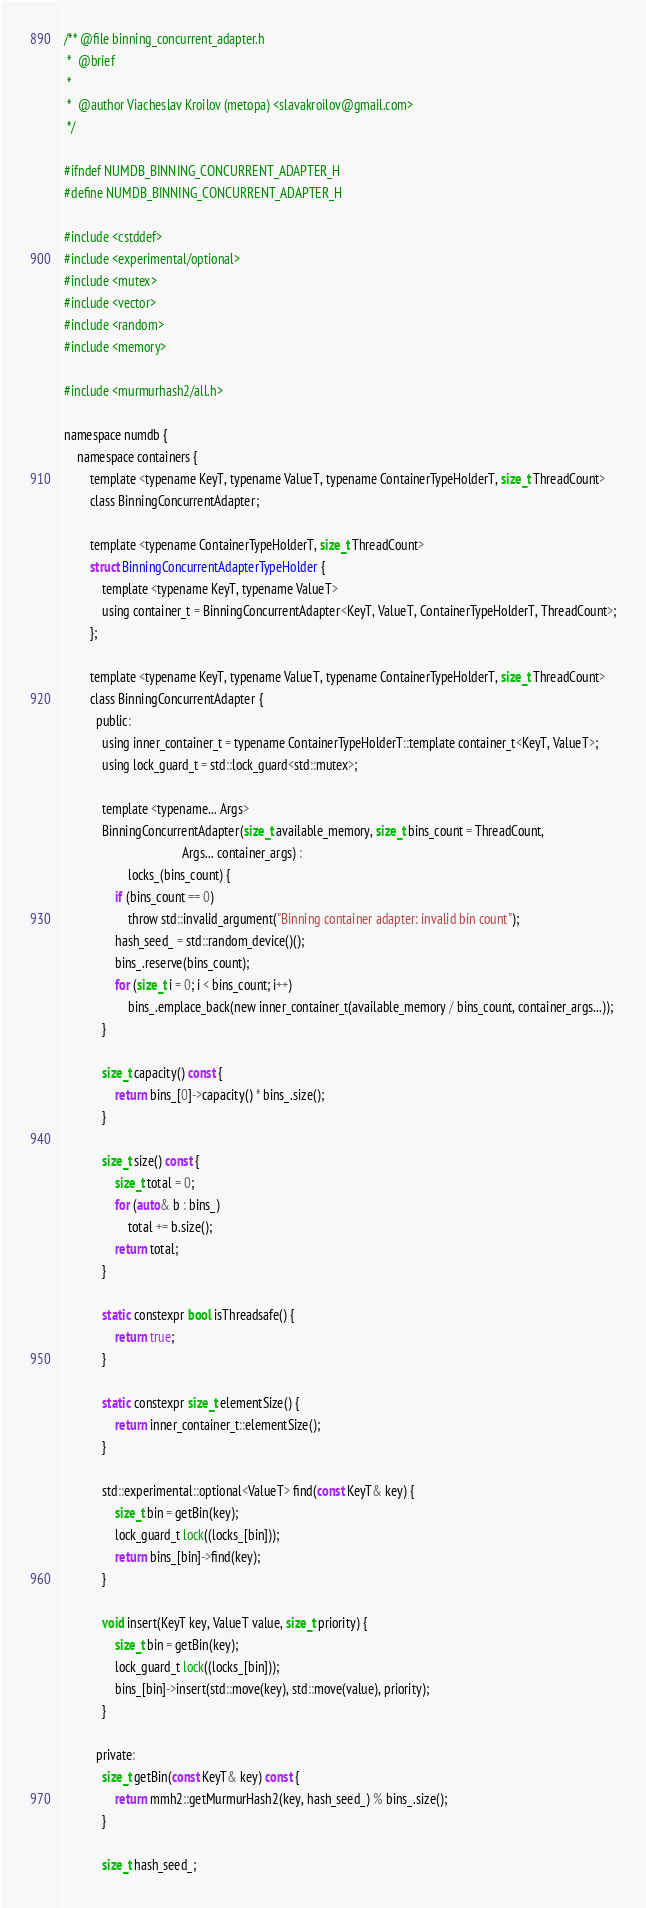Convert code to text. <code><loc_0><loc_0><loc_500><loc_500><_C_>/** @file binning_concurrent_adapter.h
 *  @brief
 *
 *  @author Viacheslav Kroilov (metopa) <slavakroilov@gmail.com>
 */

#ifndef NUMDB_BINNING_CONCURRENT_ADAPTER_H
#define NUMDB_BINNING_CONCURRENT_ADAPTER_H

#include <cstddef>
#include <experimental/optional>
#include <mutex>
#include <vector>
#include <random>
#include <memory>

#include <murmurhash2/all.h>

namespace numdb {
	namespace containers {
		template <typename KeyT, typename ValueT, typename ContainerTypeHolderT, size_t ThreadCount>
		class BinningConcurrentAdapter;

		template <typename ContainerTypeHolderT, size_t ThreadCount>
		struct BinningConcurrentAdapterTypeHolder {
			template <typename KeyT, typename ValueT>
			using container_t = BinningConcurrentAdapter<KeyT, ValueT, ContainerTypeHolderT, ThreadCount>;
		};

		template <typename KeyT, typename ValueT, typename ContainerTypeHolderT, size_t ThreadCount>
		class BinningConcurrentAdapter {
		  public:
			using inner_container_t = typename ContainerTypeHolderT::template container_t<KeyT, ValueT>;
			using lock_guard_t = std::lock_guard<std::mutex>;

			template <typename... Args>
			BinningConcurrentAdapter(size_t available_memory, size_t bins_count = ThreadCount,
									 Args... container_args) :
					locks_(bins_count) {
				if (bins_count == 0)
					throw std::invalid_argument("Binning container adapter: invalid bin count");
				hash_seed_ = std::random_device()();
				bins_.reserve(bins_count);
				for (size_t i = 0; i < bins_count; i++)
					bins_.emplace_back(new inner_container_t(available_memory / bins_count, container_args...));
			}

			size_t capacity() const {
				return bins_[0]->capacity() * bins_.size();
			}

			size_t size() const {
				size_t total = 0;
				for (auto& b : bins_)
					total += b.size();
				return total;
			}

			static constexpr bool isThreadsafe() {
				return true;
			}

			static constexpr size_t elementSize() {
				return inner_container_t::elementSize();
			}

			std::experimental::optional<ValueT> find(const KeyT& key) {
				size_t bin = getBin(key);
				lock_guard_t lock((locks_[bin]));
				return bins_[bin]->find(key);
			}

			void insert(KeyT key, ValueT value, size_t priority) {
				size_t bin = getBin(key);
				lock_guard_t lock((locks_[bin]));
				bins_[bin]->insert(std::move(key), std::move(value), priority);
			}

		  private:
			size_t getBin(const KeyT& key) const {
				return mmh2::getMurmurHash2(key, hash_seed_) % bins_.size();
			}

			size_t hash_seed_;
</code> 